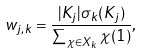Convert formula to latex. <formula><loc_0><loc_0><loc_500><loc_500>w _ { j , k } = \frac { | K _ { j } | \sigma _ { k } ( K _ { j } ) } { \sum _ { \chi \in X _ { k } } \chi ( 1 ) } ,</formula> 